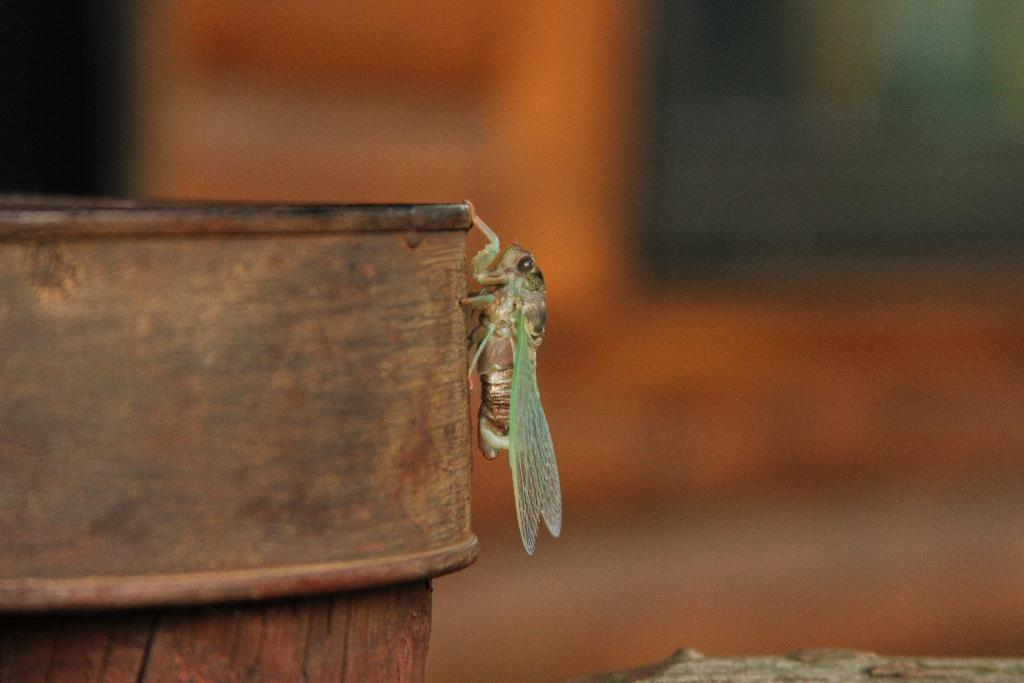What is the main subject of the image? There is an insect in the image. What type of material is the insect on? The insect is on a wooden material. How would you describe the background of the image? The background of the image is blurry. Can you describe the object in the right bottom of the image? Unfortunately, the provided facts do not give enough information to describe the object in the right bottom of the image. What type of decision is the insect making in the image? There is no indication in the image that the insect is making a decision, as insects do not have the cognitive ability to make decisions. 